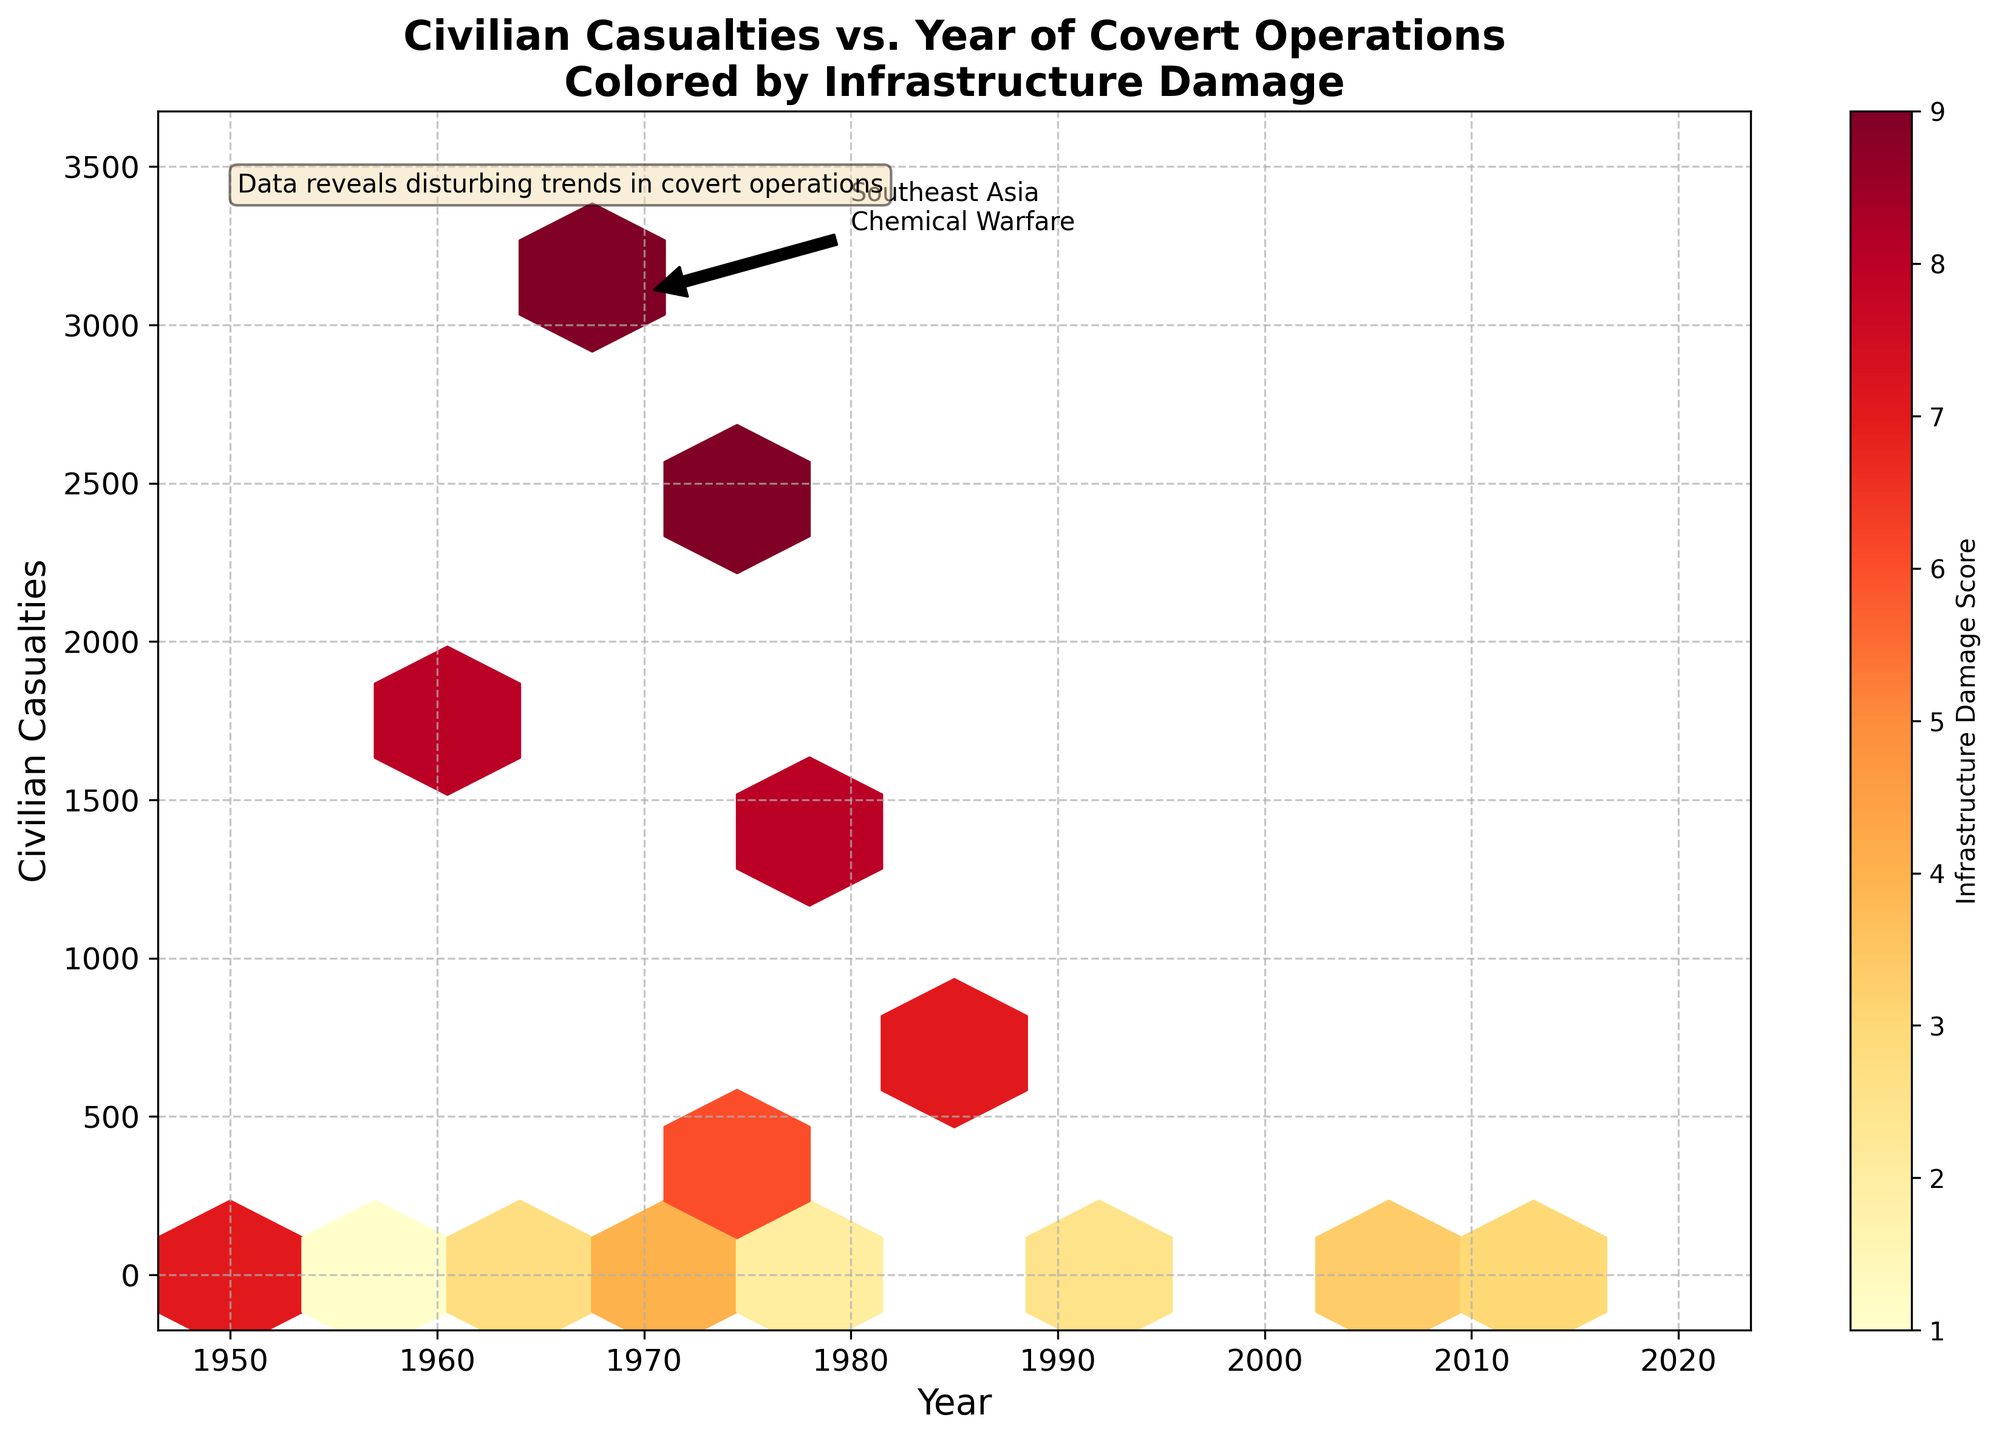What's the title of the figure? The title of the figure is located at the top and highlights the main subject of the plot, which helps viewers understand the theme immediately upon seeing it.
Answer: Civilian Casualties vs. Year of Covert Operations Colored by Infrastructure Damage What are the x and y-axis labels in this figure? The labels on the x and y axes describe what the axes represent. The x-axis represents time (Year), and the y-axis represents the number of civilian casualties.
Answer: Year; Civilian Casualties Which covert operation had the highest civilian casualties and in what year? From the figure, it's labelled that the operation in Southeast Asia involving chemical warfare in 1970 had the highest civilian casualties. This is explicitly annotated in the plot for emphasis.
Answer: Southeast Asia, 1970 What does the color represent in the Hexbin plot? The color in the Hexbin plot represents the Infrastructure Damage Score, which is indicated by the color gradient and the accompanying color bar on the right of the plot.
Answer: Infrastructure Damage Score How are the trends in civilian casualties over the years easily identified? The hexbin plot visually groups data points so we can observe general trends, such as clustering or dispersion over the years. The annotations and distribution of hexagons make it easier to see how civilian casualties have fluctuated.
Answer: Clustering and distribution of hexagons Which specific type of operation in Central America had a significant impact on civilian casualties, and in what year? The plot clearly marks the Central America Paramilitary Operation in 1981, which had a high number of civilian casualties.
Answer: Paramilitary Operation, 1981 How can the average infrastructure damage score be estimated from the plot for operations around the year 1975? By observing the color gradient around the year 1975, we can estimate that the average infrastructure damage score for operations in this period is between 6 and 7, based on the color bar.
Answer: Between 6 and 7 Is there a visible pattern in the relationship between the year of operation and civilian casualties? Yes, certain periods show more densely packed hexagons, indicating higher casualties, particularly around 1981 and 1970, while other periods have fewer casualties.
Answer: Yes, certain periods with more dense clusters What insight does the highlighted text in the plot provide? The highlighted text at the top-left indicates that the data reveals disturbing trends in covert operations, emphasizing that such operations have often resulted in significant civilian casualties and infrastructure damage.
Answer: Disturbing trends in covert operations How many regions are represented in the plot? By referring to the annotations and examining the labels, we can see that the plot covers operations in six regions: Southeast Asia, Middle East, South America, Africa, Eastern Europe, and Central America.
Answer: Six regions 